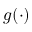Convert formula to latex. <formula><loc_0><loc_0><loc_500><loc_500>g ( \cdot )</formula> 